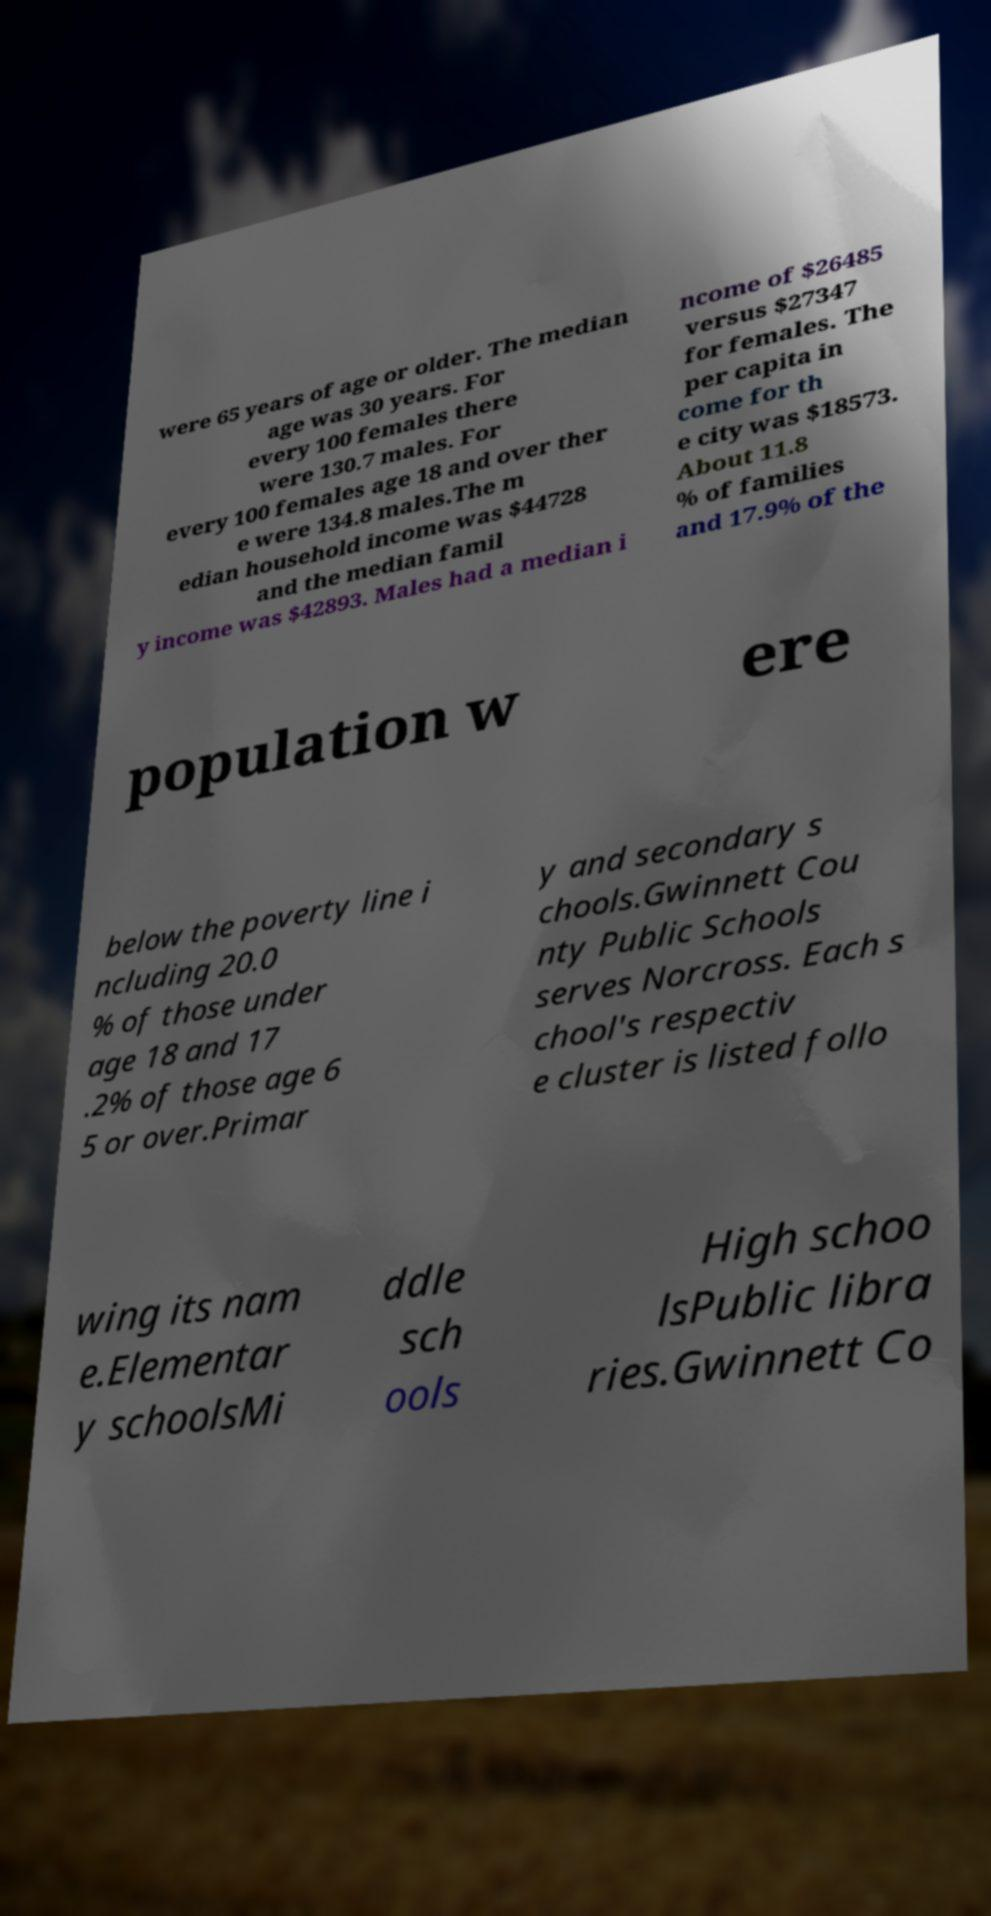Could you extract and type out the text from this image? were 65 years of age or older. The median age was 30 years. For every 100 females there were 130.7 males. For every 100 females age 18 and over ther e were 134.8 males.The m edian household income was $44728 and the median famil y income was $42893. Males had a median i ncome of $26485 versus $27347 for females. The per capita in come for th e city was $18573. About 11.8 % of families and 17.9% of the population w ere below the poverty line i ncluding 20.0 % of those under age 18 and 17 .2% of those age 6 5 or over.Primar y and secondary s chools.Gwinnett Cou nty Public Schools serves Norcross. Each s chool's respectiv e cluster is listed follo wing its nam e.Elementar y schoolsMi ddle sch ools High schoo lsPublic libra ries.Gwinnett Co 